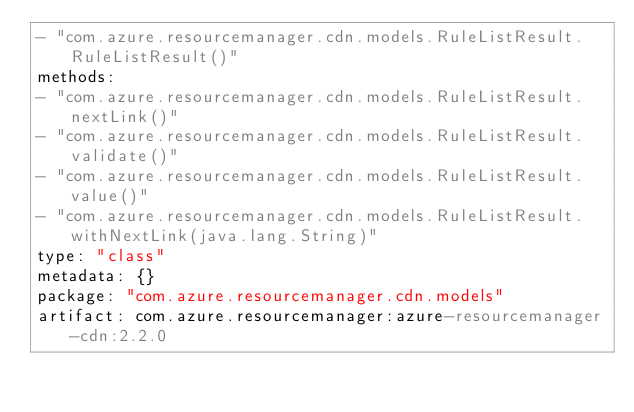Convert code to text. <code><loc_0><loc_0><loc_500><loc_500><_YAML_>- "com.azure.resourcemanager.cdn.models.RuleListResult.RuleListResult()"
methods:
- "com.azure.resourcemanager.cdn.models.RuleListResult.nextLink()"
- "com.azure.resourcemanager.cdn.models.RuleListResult.validate()"
- "com.azure.resourcemanager.cdn.models.RuleListResult.value()"
- "com.azure.resourcemanager.cdn.models.RuleListResult.withNextLink(java.lang.String)"
type: "class"
metadata: {}
package: "com.azure.resourcemanager.cdn.models"
artifact: com.azure.resourcemanager:azure-resourcemanager-cdn:2.2.0
</code> 